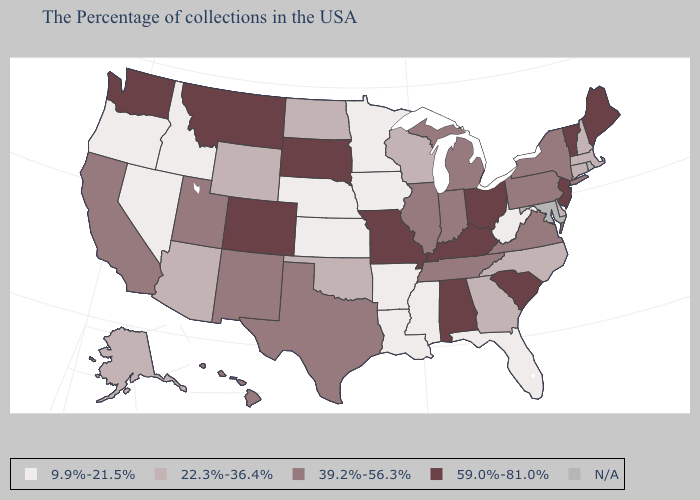Which states have the lowest value in the MidWest?
Keep it brief. Minnesota, Iowa, Kansas, Nebraska. Does the map have missing data?
Quick response, please. Yes. Name the states that have a value in the range 39.2%-56.3%?
Give a very brief answer. New York, Pennsylvania, Virginia, Michigan, Indiana, Tennessee, Illinois, Texas, New Mexico, Utah, California, Hawaii. Which states have the lowest value in the USA?
Give a very brief answer. West Virginia, Florida, Mississippi, Louisiana, Arkansas, Minnesota, Iowa, Kansas, Nebraska, Idaho, Nevada, Oregon. What is the value of Texas?
Answer briefly. 39.2%-56.3%. What is the lowest value in the MidWest?
Quick response, please. 9.9%-21.5%. Does the first symbol in the legend represent the smallest category?
Concise answer only. Yes. Among the states that border Tennessee , which have the lowest value?
Short answer required. Mississippi, Arkansas. What is the value of Utah?
Give a very brief answer. 39.2%-56.3%. Which states have the lowest value in the USA?
Write a very short answer. West Virginia, Florida, Mississippi, Louisiana, Arkansas, Minnesota, Iowa, Kansas, Nebraska, Idaho, Nevada, Oregon. Name the states that have a value in the range 59.0%-81.0%?
Be succinct. Maine, Vermont, New Jersey, South Carolina, Ohio, Kentucky, Alabama, Missouri, South Dakota, Colorado, Montana, Washington. Which states have the lowest value in the Northeast?
Answer briefly. Massachusetts, New Hampshire, Connecticut. Does Pennsylvania have the highest value in the Northeast?
Give a very brief answer. No. What is the value of Hawaii?
Concise answer only. 39.2%-56.3%. Name the states that have a value in the range 9.9%-21.5%?
Be succinct. West Virginia, Florida, Mississippi, Louisiana, Arkansas, Minnesota, Iowa, Kansas, Nebraska, Idaho, Nevada, Oregon. 